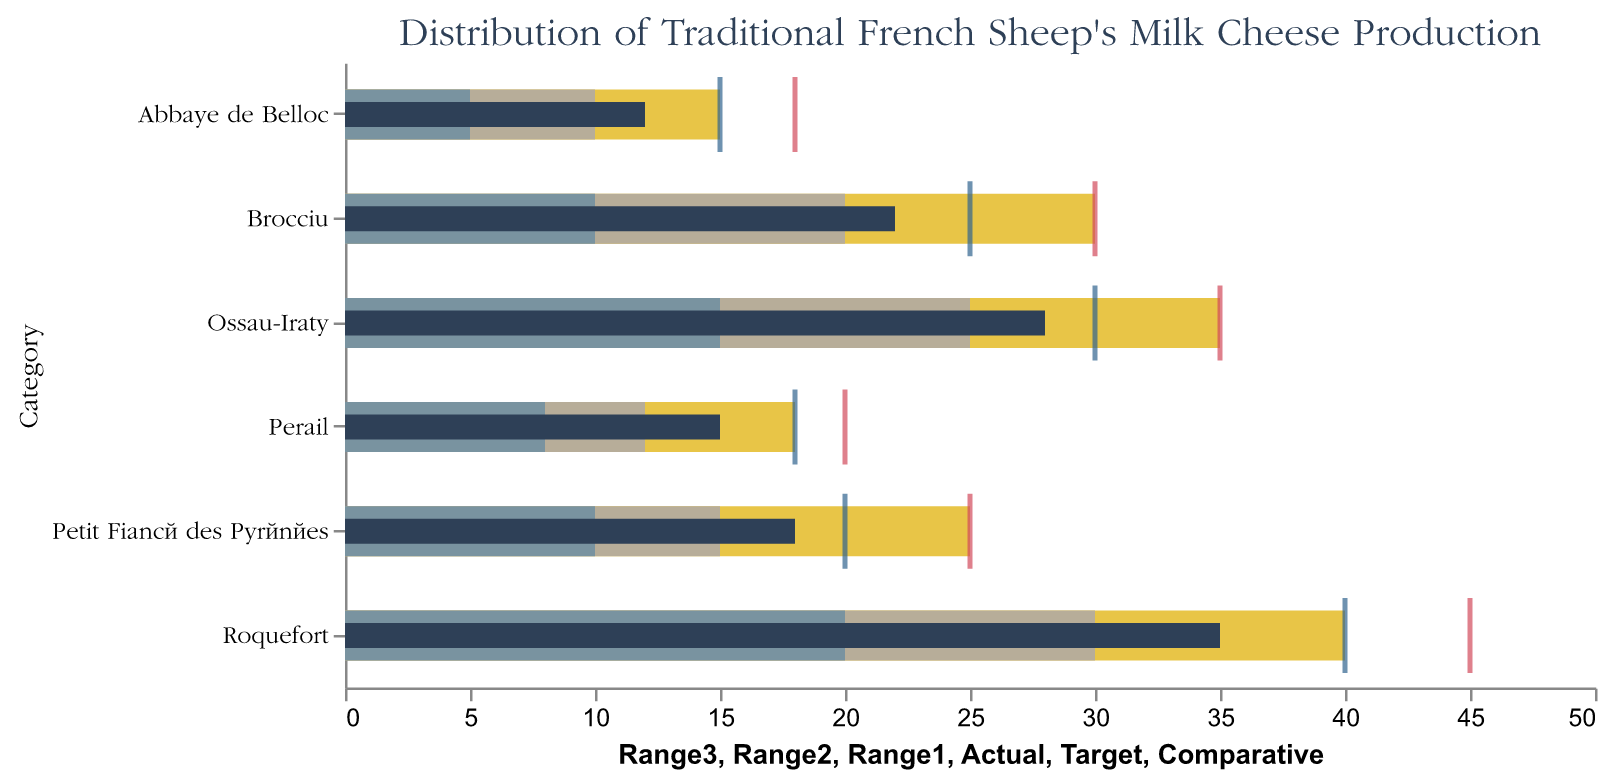What's the actual production value for Roquefort? The bar representing actual production for Roquefort is marked in dark blue color. From the chart, it extends to the value of 35.
Answer: 35 Which cheese has the highest actual production value? Looking at the actual production values marked by the dark blue bars, Roquefort has the highest value at 35.
Answer: Roquefort How does the comparative value of Ossau-Iraty compare to its actual value? The comparative value for Ossau-Iraty is represented by a tick mark in light blue, positioned at 30. The actual value is represented by a dark blue bar, positioned at 28. The comparative value (30) is greater than the actual value (28).
Answer: The comparative value is greater What is the target production value for Brocciu? The target value for Brocciu is indicated by a red tick mark, which is positioned at 30.
Answer: 30 Which cheese has the smallest difference between its comparative and actual values? For each cheese, calculate the difference between the comparative value and the actual value: Roquefort (40-35=5), Ossau-Iraty (30-28=2), Brocciu (25-22=3), Petit Fiancé des Pyrénées (20-18=2), Perail (18-15=3), Abbaye de Belloc (15-12=3). Both Ossau-Iraty and Petit Fiancé des Pyrénées have the smallest difference of 2.
Answer: Ossau-Iraty and Petit Fiancé des Pyrénées What is the range of acceptable production values (Range3) for Perail? The range of acceptable production values is depicted by the longest (yellow) bar for Perail, which extends to 18.
Answer: 18 Which cheeses' actual production values fall within their target range (Range3)? Check if the actual values (dark blue bars) fall within Range3 (longest yellow bars) for each cheese: Roquefort (35 <= 40), Ossau-Iraty (28 <= 35), Brocciu (22 <= 30), Petit Fiancé des Pyrénées (18 <= 25), Perail (15 <= 18), Abbaye de Belloc (12 <= 15). All cheeses' actual production values fit within their target range.
Answer: All the cheeses What's the total target production value for all the cheeses? Sum the target values for all cheeses: 45 (Roquefort) + 35 (Ossau-Iraty) + 30 (Brocciu) + 25 (Petit Fiancé des Pyrénées) + 20 (Perail) + 18 (Abbaye de Belloc) = 173.
Answer: 173 Between Roquefort and Brocciu, which has a production closer to its target and by how much? Calculate the difference between the actual values and target values: Roquefort (45-35=10), Brocciu (30-22=8). Brocciu has a closer production value to its target. The difference for Brocciu is 8, whereas for Roquefort it is 10.
Answer: Brocciu, by 2 